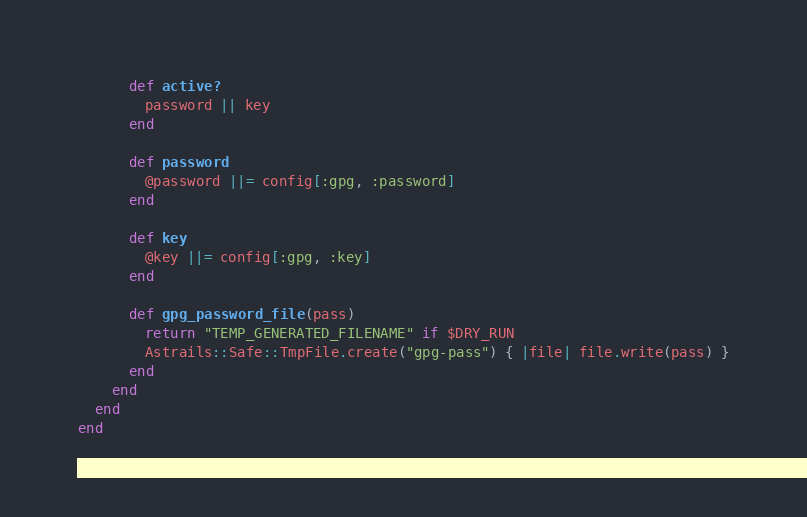Convert code to text. <code><loc_0><loc_0><loc_500><loc_500><_Ruby_>      def active?
        password || key
      end

      def password
        @password ||= config[:gpg, :password]
      end

      def key
        @key ||= config[:gpg, :key]
      end

      def gpg_password_file(pass)
        return "TEMP_GENERATED_FILENAME" if $DRY_RUN
        Astrails::Safe::TmpFile.create("gpg-pass") { |file| file.write(pass) }
      end
    end
  end
end
</code> 